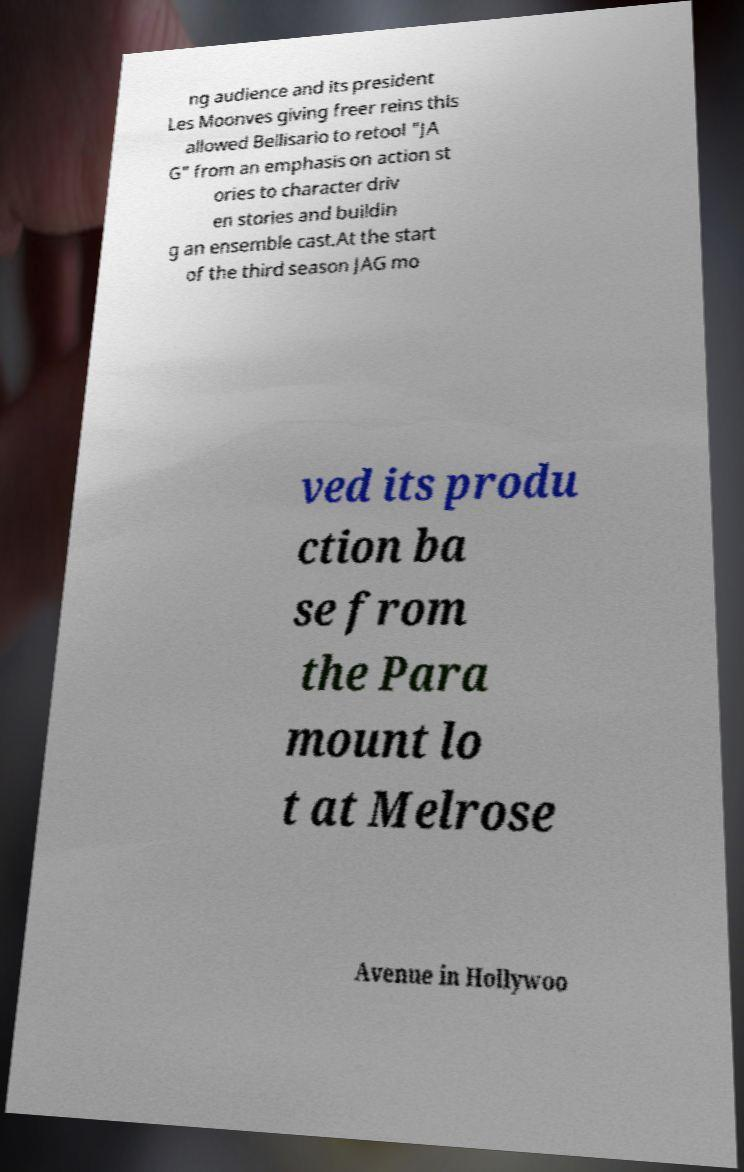For documentation purposes, I need the text within this image transcribed. Could you provide that? ng audience and its president Les Moonves giving freer reins this allowed Bellisario to retool "JA G" from an emphasis on action st ories to character driv en stories and buildin g an ensemble cast.At the start of the third season JAG mo ved its produ ction ba se from the Para mount lo t at Melrose Avenue in Hollywoo 